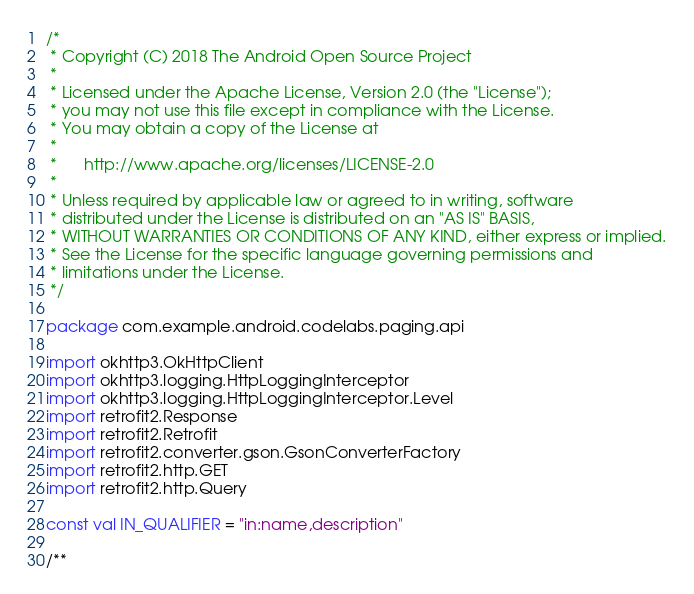Convert code to text. <code><loc_0><loc_0><loc_500><loc_500><_Kotlin_>/*
 * Copyright (C) 2018 The Android Open Source Project
 *
 * Licensed under the Apache License, Version 2.0 (the "License");
 * you may not use this file except in compliance with the License.
 * You may obtain a copy of the License at
 *
 *      http://www.apache.org/licenses/LICENSE-2.0
 *
 * Unless required by applicable law or agreed to in writing, software
 * distributed under the License is distributed on an "AS IS" BASIS,
 * WITHOUT WARRANTIES OR CONDITIONS OF ANY KIND, either express or implied.
 * See the License for the specific language governing permissions and
 * limitations under the License.
 */

package com.example.android.codelabs.paging.api

import okhttp3.OkHttpClient
import okhttp3.logging.HttpLoggingInterceptor
import okhttp3.logging.HttpLoggingInterceptor.Level
import retrofit2.Response
import retrofit2.Retrofit
import retrofit2.converter.gson.GsonConverterFactory
import retrofit2.http.GET
import retrofit2.http.Query

const val IN_QUALIFIER = "in:name,description"

/**</code> 